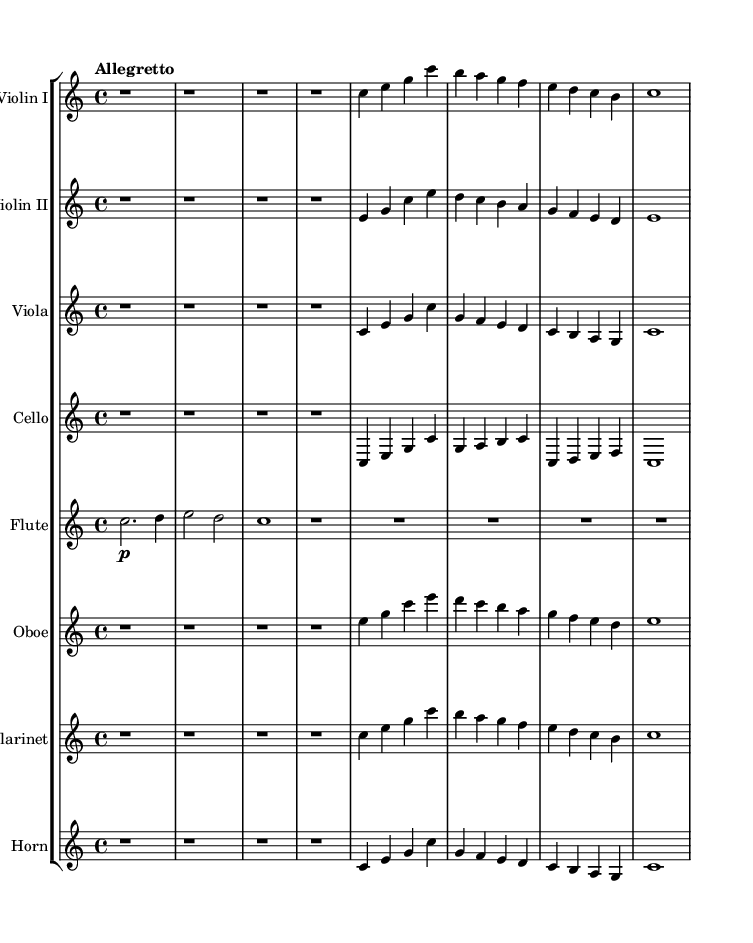What is the key signature of this music? The key signature is indicated by the absence of sharps or flats at the beginning of the staff. In this case, it is C major, which has no accidentals.
Answer: C major What is the time signature of the piece? The time signature is found at the beginning of the score right after the key signature. It shows 4/4, indicating four beats per measure with a quarter note receiving one beat.
Answer: 4/4 What is the tempo marking for this symphony? The tempo is indicated at the beginning of the score with the term "Allegretto," which is a moderately fast tempo.
Answer: Allegretto How many instruments are included in the score? The score lists eight different instrumental staves, including two violins, viola, cello, flute, oboe, clarinet, and horn. Thus, there are a total of eight instruments.
Answer: Eight Describe the structure of the theme. The theme starts with an introduction consisting of rests, followed by melodies for each instrument that share a similar framework. The pattern repeats and uses simple intervals, highlighting a childlike essence.
Answer: Introduction and Theme A What do the rests at the beginning signify? The rests at the beginning of each instrument indicate silence in those measures, which sets up the introduction before the first theme begins. This is common in classical pieces to build anticipation.
Answer: Silence Which instrument plays the first melody? The violin I part contains the first melody after the rests in the introduction. It initiates the thematic material for the piece.
Answer: Violin I 